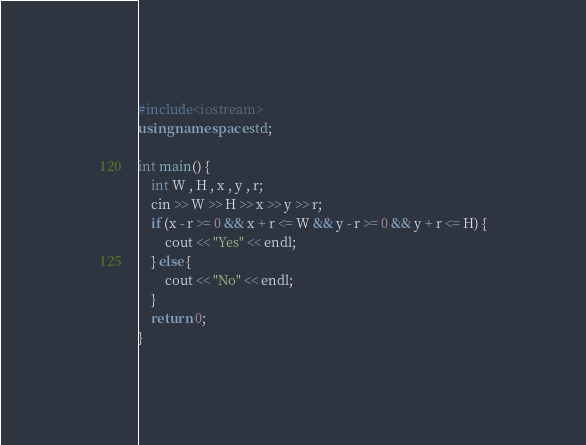<code> <loc_0><loc_0><loc_500><loc_500><_C++_>#include<iostream>
using namespace std;

int main() {
    int W , H , x , y , r;
    cin >> W >> H >> x >> y >> r;
    if (x - r >= 0 && x + r <= W && y - r >= 0 && y + r <= H) {
        cout << "Yes" << endl;
    } else {
        cout << "No" << endl;
    }
    return 0;
}
</code> 